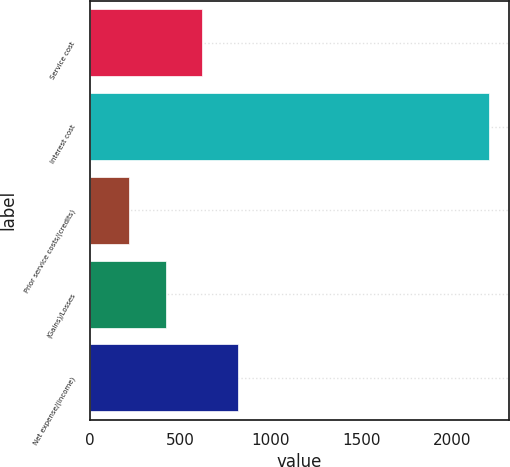Convert chart. <chart><loc_0><loc_0><loc_500><loc_500><bar_chart><fcel>Service cost<fcel>Interest cost<fcel>Prior service costs/(credits)<fcel>(Gains)/Losses<fcel>Net expense/(income)<nl><fcel>623.8<fcel>2208<fcel>220<fcel>425<fcel>822.6<nl></chart> 